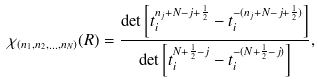Convert formula to latex. <formula><loc_0><loc_0><loc_500><loc_500>\chi _ { ( n _ { 1 } , n _ { 2 } , \dots , n _ { N } ) } ( R ) = \frac { \det \left [ t _ { i } ^ { n _ { j } + N - j + \frac { 1 } { 2 } } - t _ { i } ^ { - ( n _ { j } + N - j + \frac { 1 } { 2 } ) } \right ] } { \det \left [ t _ { i } ^ { N + \frac { 1 } { 2 } - j } - t _ { i } ^ { - ( N + \frac { 1 } { 2 } - j ) } \right ] } ,</formula> 